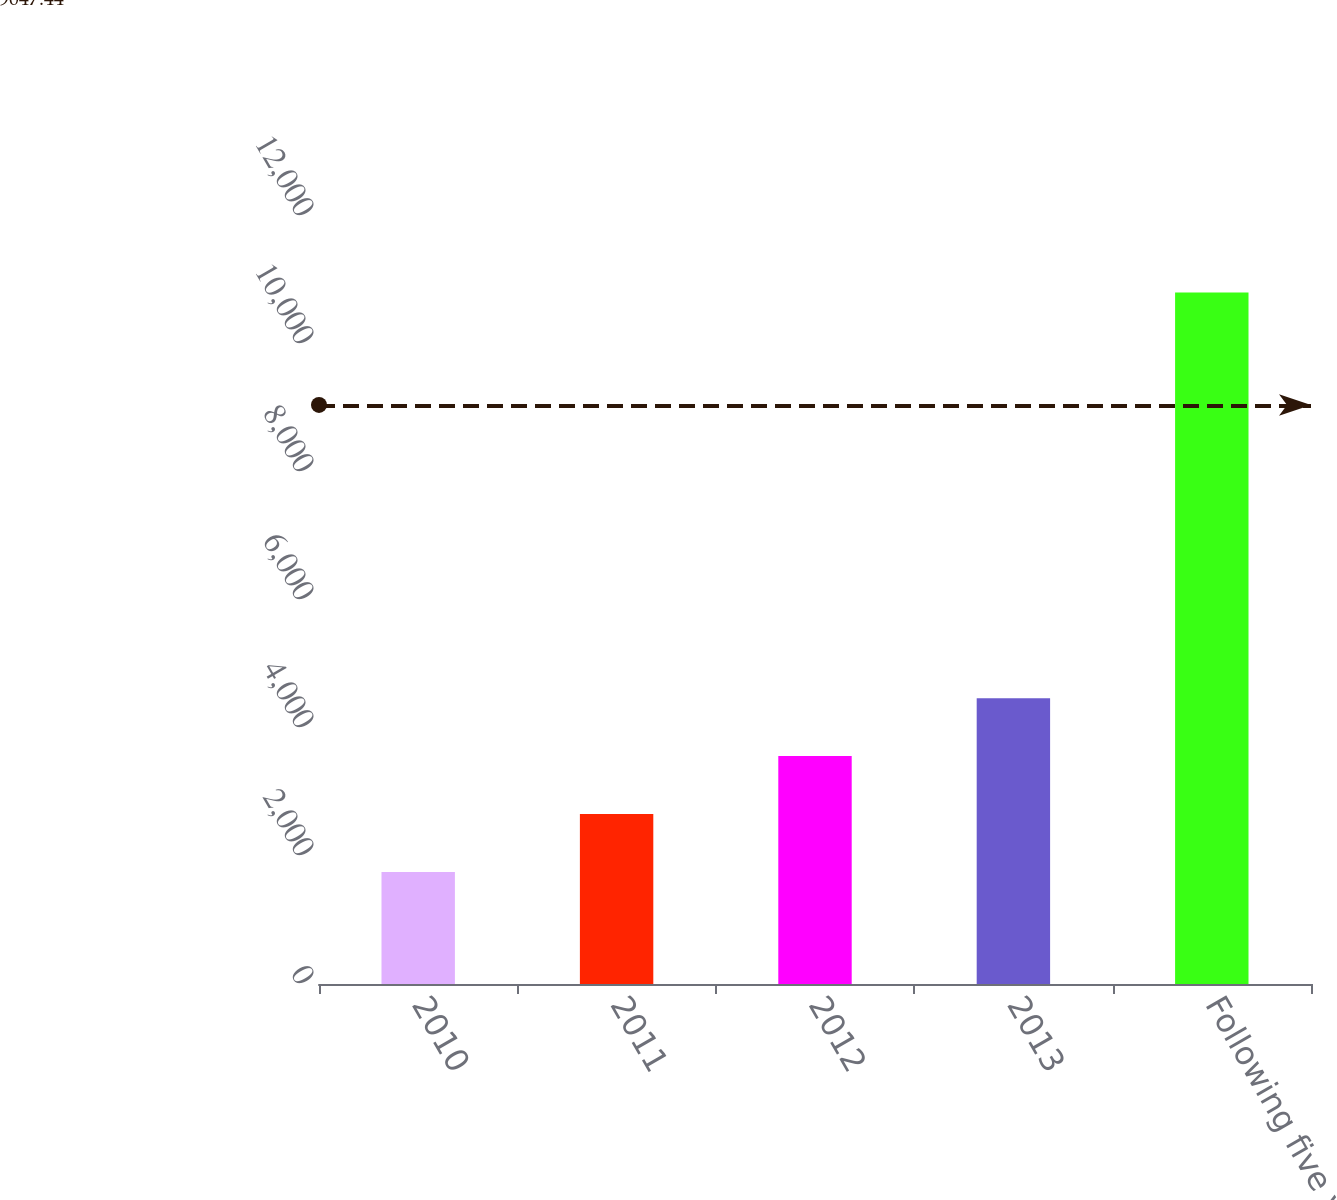Convert chart. <chart><loc_0><loc_0><loc_500><loc_500><bar_chart><fcel>2010<fcel>2011<fcel>2012<fcel>2013<fcel>Following five years<nl><fcel>1750<fcel>2655.4<fcel>3560.8<fcel>4466.2<fcel>10804<nl></chart> 